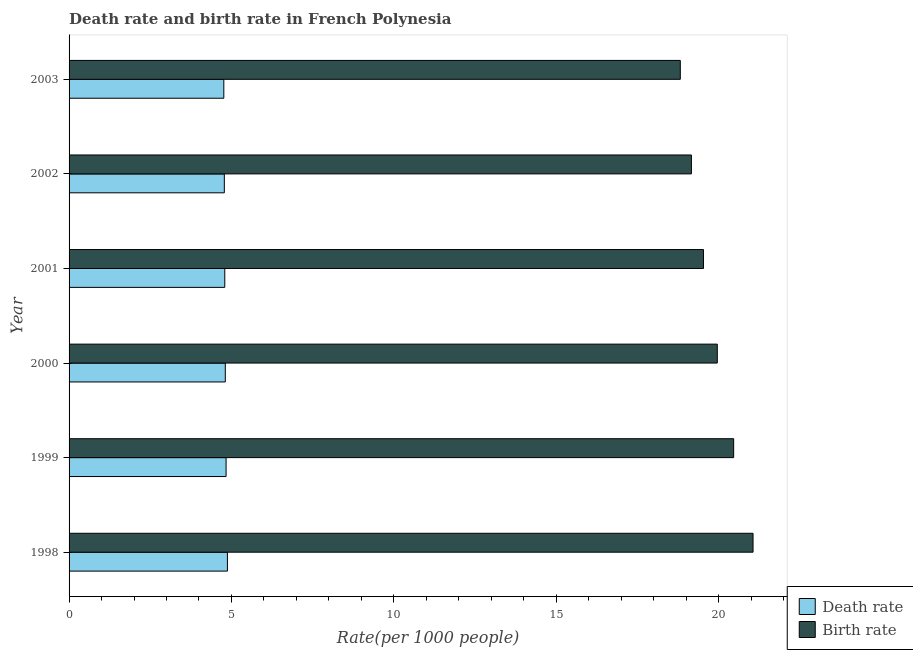How many different coloured bars are there?
Offer a terse response. 2. Are the number of bars per tick equal to the number of legend labels?
Offer a very short reply. Yes. How many bars are there on the 3rd tick from the top?
Your response must be concise. 2. What is the label of the 3rd group of bars from the top?
Offer a very short reply. 2001. In how many cases, is the number of bars for a given year not equal to the number of legend labels?
Keep it short and to the point. 0. What is the death rate in 1998?
Provide a succinct answer. 4.88. Across all years, what is the maximum death rate?
Offer a very short reply. 4.88. Across all years, what is the minimum death rate?
Give a very brief answer. 4.76. In which year was the death rate minimum?
Your response must be concise. 2003. What is the total death rate in the graph?
Offer a terse response. 28.86. What is the difference between the birth rate in 2000 and that in 2001?
Your response must be concise. 0.42. What is the difference between the death rate in 2002 and the birth rate in 2003?
Offer a very short reply. -14.04. What is the average death rate per year?
Your answer should be very brief. 4.81. In the year 1999, what is the difference between the birth rate and death rate?
Your answer should be compact. 15.63. In how many years, is the birth rate greater than 11 ?
Give a very brief answer. 6. What is the ratio of the birth rate in 2000 to that in 2003?
Offer a terse response. 1.06. What is the difference between the highest and the second highest death rate?
Your response must be concise. 0.04. What is the difference between the highest and the lowest death rate?
Ensure brevity in your answer.  0.11. In how many years, is the death rate greater than the average death rate taken over all years?
Make the answer very short. 3. Is the sum of the death rate in 1999 and 2001 greater than the maximum birth rate across all years?
Ensure brevity in your answer.  No. What does the 1st bar from the top in 2001 represents?
Offer a very short reply. Birth rate. What does the 1st bar from the bottom in 2001 represents?
Provide a succinct answer. Death rate. Are all the bars in the graph horizontal?
Your response must be concise. Yes. What is the difference between two consecutive major ticks on the X-axis?
Make the answer very short. 5. Where does the legend appear in the graph?
Your answer should be compact. Bottom right. How many legend labels are there?
Ensure brevity in your answer.  2. How are the legend labels stacked?
Your answer should be very brief. Vertical. What is the title of the graph?
Provide a short and direct response. Death rate and birth rate in French Polynesia. What is the label or title of the X-axis?
Your response must be concise. Rate(per 1000 people). What is the label or title of the Y-axis?
Offer a very short reply. Year. What is the Rate(per 1000 people) of Death rate in 1998?
Keep it short and to the point. 4.88. What is the Rate(per 1000 people) in Birth rate in 1998?
Your answer should be compact. 21.06. What is the Rate(per 1000 people) in Death rate in 1999?
Give a very brief answer. 4.83. What is the Rate(per 1000 people) in Birth rate in 1999?
Your answer should be very brief. 20.46. What is the Rate(per 1000 people) in Death rate in 2000?
Your response must be concise. 4.81. What is the Rate(per 1000 people) of Birth rate in 2000?
Provide a short and direct response. 19.96. What is the Rate(per 1000 people) of Death rate in 2001?
Give a very brief answer. 4.79. What is the Rate(per 1000 people) in Birth rate in 2001?
Ensure brevity in your answer.  19.54. What is the Rate(per 1000 people) in Death rate in 2002?
Ensure brevity in your answer.  4.78. What is the Rate(per 1000 people) in Birth rate in 2002?
Ensure brevity in your answer.  19.16. What is the Rate(per 1000 people) of Death rate in 2003?
Provide a short and direct response. 4.76. What is the Rate(per 1000 people) in Birth rate in 2003?
Provide a succinct answer. 18.82. Across all years, what is the maximum Rate(per 1000 people) in Death rate?
Offer a terse response. 4.88. Across all years, what is the maximum Rate(per 1000 people) in Birth rate?
Give a very brief answer. 21.06. Across all years, what is the minimum Rate(per 1000 people) of Death rate?
Make the answer very short. 4.76. Across all years, what is the minimum Rate(per 1000 people) of Birth rate?
Ensure brevity in your answer.  18.82. What is the total Rate(per 1000 people) of Death rate in the graph?
Offer a terse response. 28.86. What is the total Rate(per 1000 people) of Birth rate in the graph?
Your answer should be very brief. 119.01. What is the difference between the Rate(per 1000 people) in Death rate in 1998 and that in 1999?
Make the answer very short. 0.04. What is the difference between the Rate(per 1000 people) of Birth rate in 1998 and that in 1999?
Keep it short and to the point. 0.6. What is the difference between the Rate(per 1000 people) in Death rate in 1998 and that in 2000?
Offer a very short reply. 0.07. What is the difference between the Rate(per 1000 people) in Birth rate in 1998 and that in 2000?
Provide a succinct answer. 1.1. What is the difference between the Rate(per 1000 people) in Death rate in 1998 and that in 2001?
Provide a short and direct response. 0.08. What is the difference between the Rate(per 1000 people) in Birth rate in 1998 and that in 2001?
Give a very brief answer. 1.53. What is the difference between the Rate(per 1000 people) in Death rate in 1998 and that in 2002?
Provide a short and direct response. 0.1. What is the difference between the Rate(per 1000 people) of Birth rate in 1998 and that in 2002?
Your answer should be very brief. 1.9. What is the difference between the Rate(per 1000 people) in Death rate in 1998 and that in 2003?
Provide a succinct answer. 0.11. What is the difference between the Rate(per 1000 people) in Birth rate in 1998 and that in 2003?
Give a very brief answer. 2.24. What is the difference between the Rate(per 1000 people) of Death rate in 1999 and that in 2000?
Your response must be concise. 0.02. What is the difference between the Rate(per 1000 people) of Birth rate in 1999 and that in 2000?
Your answer should be compact. 0.5. What is the difference between the Rate(per 1000 people) of Birth rate in 1999 and that in 2001?
Make the answer very short. 0.93. What is the difference between the Rate(per 1000 people) of Death rate in 1999 and that in 2002?
Provide a succinct answer. 0.05. What is the difference between the Rate(per 1000 people) in Birth rate in 1999 and that in 2002?
Provide a short and direct response. 1.3. What is the difference between the Rate(per 1000 people) of Death rate in 1999 and that in 2003?
Offer a very short reply. 0.07. What is the difference between the Rate(per 1000 people) of Birth rate in 1999 and that in 2003?
Make the answer very short. 1.64. What is the difference between the Rate(per 1000 people) of Death rate in 2000 and that in 2001?
Offer a terse response. 0.02. What is the difference between the Rate(per 1000 people) of Birth rate in 2000 and that in 2001?
Provide a succinct answer. 0.42. What is the difference between the Rate(per 1000 people) in Birth rate in 2000 and that in 2002?
Keep it short and to the point. 0.8. What is the difference between the Rate(per 1000 people) in Death rate in 2000 and that in 2003?
Ensure brevity in your answer.  0.05. What is the difference between the Rate(per 1000 people) of Birth rate in 2000 and that in 2003?
Provide a short and direct response. 1.14. What is the difference between the Rate(per 1000 people) in Death rate in 2001 and that in 2002?
Your answer should be very brief. 0.01. What is the difference between the Rate(per 1000 people) in Birth rate in 2001 and that in 2002?
Make the answer very short. 0.37. What is the difference between the Rate(per 1000 people) in Death rate in 2001 and that in 2003?
Offer a very short reply. 0.03. What is the difference between the Rate(per 1000 people) in Birth rate in 2001 and that in 2003?
Offer a very short reply. 0.71. What is the difference between the Rate(per 1000 people) of Death rate in 2002 and that in 2003?
Give a very brief answer. 0.02. What is the difference between the Rate(per 1000 people) in Birth rate in 2002 and that in 2003?
Provide a short and direct response. 0.34. What is the difference between the Rate(per 1000 people) in Death rate in 1998 and the Rate(per 1000 people) in Birth rate in 1999?
Provide a succinct answer. -15.59. What is the difference between the Rate(per 1000 people) of Death rate in 1998 and the Rate(per 1000 people) of Birth rate in 2000?
Make the answer very short. -15.09. What is the difference between the Rate(per 1000 people) in Death rate in 1998 and the Rate(per 1000 people) in Birth rate in 2001?
Your response must be concise. -14.66. What is the difference between the Rate(per 1000 people) in Death rate in 1998 and the Rate(per 1000 people) in Birth rate in 2002?
Provide a succinct answer. -14.29. What is the difference between the Rate(per 1000 people) in Death rate in 1998 and the Rate(per 1000 people) in Birth rate in 2003?
Your answer should be very brief. -13.95. What is the difference between the Rate(per 1000 people) of Death rate in 1999 and the Rate(per 1000 people) of Birth rate in 2000?
Make the answer very short. -15.13. What is the difference between the Rate(per 1000 people) of Death rate in 1999 and the Rate(per 1000 people) of Birth rate in 2001?
Your answer should be very brief. -14.7. What is the difference between the Rate(per 1000 people) of Death rate in 1999 and the Rate(per 1000 people) of Birth rate in 2002?
Make the answer very short. -14.33. What is the difference between the Rate(per 1000 people) in Death rate in 1999 and the Rate(per 1000 people) in Birth rate in 2003?
Your response must be concise. -13.99. What is the difference between the Rate(per 1000 people) in Death rate in 2000 and the Rate(per 1000 people) in Birth rate in 2001?
Offer a very short reply. -14.72. What is the difference between the Rate(per 1000 people) of Death rate in 2000 and the Rate(per 1000 people) of Birth rate in 2002?
Provide a succinct answer. -14.35. What is the difference between the Rate(per 1000 people) of Death rate in 2000 and the Rate(per 1000 people) of Birth rate in 2003?
Provide a short and direct response. -14.01. What is the difference between the Rate(per 1000 people) of Death rate in 2001 and the Rate(per 1000 people) of Birth rate in 2002?
Provide a succinct answer. -14.37. What is the difference between the Rate(per 1000 people) of Death rate in 2001 and the Rate(per 1000 people) of Birth rate in 2003?
Ensure brevity in your answer.  -14.03. What is the difference between the Rate(per 1000 people) in Death rate in 2002 and the Rate(per 1000 people) in Birth rate in 2003?
Give a very brief answer. -14.04. What is the average Rate(per 1000 people) in Death rate per year?
Your answer should be very brief. 4.81. What is the average Rate(per 1000 people) in Birth rate per year?
Your response must be concise. 19.84. In the year 1998, what is the difference between the Rate(per 1000 people) in Death rate and Rate(per 1000 people) in Birth rate?
Keep it short and to the point. -16.19. In the year 1999, what is the difference between the Rate(per 1000 people) in Death rate and Rate(per 1000 people) in Birth rate?
Offer a terse response. -15.63. In the year 2000, what is the difference between the Rate(per 1000 people) in Death rate and Rate(per 1000 people) in Birth rate?
Keep it short and to the point. -15.15. In the year 2001, what is the difference between the Rate(per 1000 people) in Death rate and Rate(per 1000 people) in Birth rate?
Give a very brief answer. -14.74. In the year 2002, what is the difference between the Rate(per 1000 people) of Death rate and Rate(per 1000 people) of Birth rate?
Your answer should be very brief. -14.38. In the year 2003, what is the difference between the Rate(per 1000 people) in Death rate and Rate(per 1000 people) in Birth rate?
Provide a succinct answer. -14.06. What is the ratio of the Rate(per 1000 people) of Death rate in 1998 to that in 1999?
Provide a succinct answer. 1.01. What is the ratio of the Rate(per 1000 people) in Birth rate in 1998 to that in 1999?
Offer a very short reply. 1.03. What is the ratio of the Rate(per 1000 people) of Death rate in 1998 to that in 2000?
Provide a short and direct response. 1.01. What is the ratio of the Rate(per 1000 people) of Birth rate in 1998 to that in 2000?
Offer a terse response. 1.06. What is the ratio of the Rate(per 1000 people) of Death rate in 1998 to that in 2001?
Your answer should be very brief. 1.02. What is the ratio of the Rate(per 1000 people) of Birth rate in 1998 to that in 2001?
Make the answer very short. 1.08. What is the ratio of the Rate(per 1000 people) of Death rate in 1998 to that in 2002?
Your response must be concise. 1.02. What is the ratio of the Rate(per 1000 people) of Birth rate in 1998 to that in 2002?
Offer a terse response. 1.1. What is the ratio of the Rate(per 1000 people) of Death rate in 1998 to that in 2003?
Your answer should be compact. 1.02. What is the ratio of the Rate(per 1000 people) of Birth rate in 1998 to that in 2003?
Provide a short and direct response. 1.12. What is the ratio of the Rate(per 1000 people) of Birth rate in 1999 to that in 2000?
Offer a terse response. 1.03. What is the ratio of the Rate(per 1000 people) in Death rate in 1999 to that in 2001?
Provide a succinct answer. 1.01. What is the ratio of the Rate(per 1000 people) in Birth rate in 1999 to that in 2001?
Keep it short and to the point. 1.05. What is the ratio of the Rate(per 1000 people) of Death rate in 1999 to that in 2002?
Offer a terse response. 1.01. What is the ratio of the Rate(per 1000 people) of Birth rate in 1999 to that in 2002?
Provide a succinct answer. 1.07. What is the ratio of the Rate(per 1000 people) of Death rate in 1999 to that in 2003?
Offer a terse response. 1.01. What is the ratio of the Rate(per 1000 people) of Birth rate in 1999 to that in 2003?
Offer a very short reply. 1.09. What is the ratio of the Rate(per 1000 people) in Death rate in 2000 to that in 2001?
Provide a succinct answer. 1. What is the ratio of the Rate(per 1000 people) of Birth rate in 2000 to that in 2001?
Offer a terse response. 1.02. What is the ratio of the Rate(per 1000 people) of Death rate in 2000 to that in 2002?
Offer a terse response. 1.01. What is the ratio of the Rate(per 1000 people) in Birth rate in 2000 to that in 2002?
Ensure brevity in your answer.  1.04. What is the ratio of the Rate(per 1000 people) in Death rate in 2000 to that in 2003?
Offer a terse response. 1.01. What is the ratio of the Rate(per 1000 people) of Birth rate in 2000 to that in 2003?
Your answer should be compact. 1.06. What is the ratio of the Rate(per 1000 people) in Birth rate in 2001 to that in 2002?
Provide a short and direct response. 1.02. What is the ratio of the Rate(per 1000 people) of Death rate in 2001 to that in 2003?
Offer a very short reply. 1.01. What is the ratio of the Rate(per 1000 people) in Birth rate in 2001 to that in 2003?
Make the answer very short. 1.04. What is the ratio of the Rate(per 1000 people) of Birth rate in 2002 to that in 2003?
Offer a terse response. 1.02. What is the difference between the highest and the second highest Rate(per 1000 people) of Death rate?
Provide a succinct answer. 0.04. What is the difference between the highest and the second highest Rate(per 1000 people) of Birth rate?
Ensure brevity in your answer.  0.6. What is the difference between the highest and the lowest Rate(per 1000 people) in Death rate?
Give a very brief answer. 0.11. What is the difference between the highest and the lowest Rate(per 1000 people) of Birth rate?
Offer a very short reply. 2.24. 